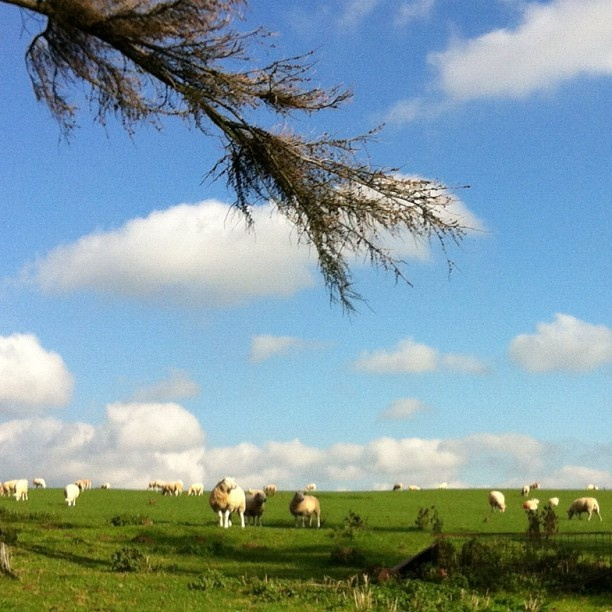Describe the objects in this image and their specific colors. I can see sheep in black, tan, olive, and beige tones, sheep in black, khaki, lightyellow, tan, and olive tones, sheep in black, olive, and khaki tones, sheep in black, darkgreen, and tan tones, and sheep in black, olive, and khaki tones in this image. 